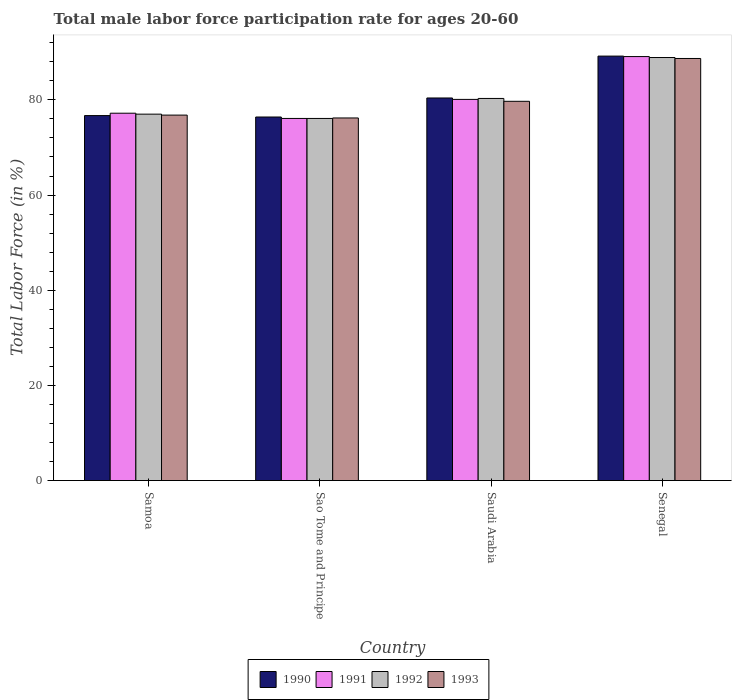How many bars are there on the 1st tick from the left?
Offer a terse response. 4. What is the label of the 1st group of bars from the left?
Offer a terse response. Samoa. What is the male labor force participation rate in 1990 in Sao Tome and Principe?
Make the answer very short. 76.4. Across all countries, what is the maximum male labor force participation rate in 1991?
Your answer should be very brief. 89.1. Across all countries, what is the minimum male labor force participation rate in 1993?
Your answer should be very brief. 76.2. In which country was the male labor force participation rate in 1992 maximum?
Give a very brief answer. Senegal. In which country was the male labor force participation rate in 1993 minimum?
Keep it short and to the point. Sao Tome and Principe. What is the total male labor force participation rate in 1990 in the graph?
Your response must be concise. 322.7. What is the difference between the male labor force participation rate in 1992 in Sao Tome and Principe and that in Saudi Arabia?
Offer a very short reply. -4.2. What is the average male labor force participation rate in 1993 per country?
Offer a very short reply. 80.35. What is the difference between the male labor force participation rate of/in 1990 and male labor force participation rate of/in 1993 in Saudi Arabia?
Keep it short and to the point. 0.7. In how many countries, is the male labor force participation rate in 1990 greater than 52 %?
Your answer should be very brief. 4. What is the ratio of the male labor force participation rate in 1990 in Samoa to that in Saudi Arabia?
Provide a short and direct response. 0.95. Is the difference between the male labor force participation rate in 1990 in Sao Tome and Principe and Senegal greater than the difference between the male labor force participation rate in 1993 in Sao Tome and Principe and Senegal?
Provide a short and direct response. No. What is the difference between the highest and the second highest male labor force participation rate in 1993?
Offer a very short reply. 11.9. In how many countries, is the male labor force participation rate in 1992 greater than the average male labor force participation rate in 1992 taken over all countries?
Provide a short and direct response. 1. Is the sum of the male labor force participation rate in 1993 in Sao Tome and Principe and Senegal greater than the maximum male labor force participation rate in 1991 across all countries?
Your answer should be very brief. Yes. How many countries are there in the graph?
Give a very brief answer. 4. What is the difference between two consecutive major ticks on the Y-axis?
Offer a terse response. 20. Does the graph contain grids?
Your answer should be compact. No. How are the legend labels stacked?
Offer a terse response. Horizontal. What is the title of the graph?
Make the answer very short. Total male labor force participation rate for ages 20-60. Does "2012" appear as one of the legend labels in the graph?
Give a very brief answer. No. What is the label or title of the X-axis?
Your response must be concise. Country. What is the Total Labor Force (in %) of 1990 in Samoa?
Give a very brief answer. 76.7. What is the Total Labor Force (in %) of 1991 in Samoa?
Your answer should be very brief. 77.2. What is the Total Labor Force (in %) in 1992 in Samoa?
Your answer should be very brief. 77. What is the Total Labor Force (in %) in 1993 in Samoa?
Make the answer very short. 76.8. What is the Total Labor Force (in %) of 1990 in Sao Tome and Principe?
Provide a succinct answer. 76.4. What is the Total Labor Force (in %) of 1991 in Sao Tome and Principe?
Keep it short and to the point. 76.1. What is the Total Labor Force (in %) in 1992 in Sao Tome and Principe?
Provide a short and direct response. 76.1. What is the Total Labor Force (in %) in 1993 in Sao Tome and Principe?
Ensure brevity in your answer.  76.2. What is the Total Labor Force (in %) of 1990 in Saudi Arabia?
Ensure brevity in your answer.  80.4. What is the Total Labor Force (in %) of 1991 in Saudi Arabia?
Provide a short and direct response. 80.1. What is the Total Labor Force (in %) in 1992 in Saudi Arabia?
Offer a terse response. 80.3. What is the Total Labor Force (in %) in 1993 in Saudi Arabia?
Your response must be concise. 79.7. What is the Total Labor Force (in %) of 1990 in Senegal?
Your response must be concise. 89.2. What is the Total Labor Force (in %) of 1991 in Senegal?
Offer a terse response. 89.1. What is the Total Labor Force (in %) in 1992 in Senegal?
Ensure brevity in your answer.  88.9. What is the Total Labor Force (in %) in 1993 in Senegal?
Your answer should be very brief. 88.7. Across all countries, what is the maximum Total Labor Force (in %) of 1990?
Offer a very short reply. 89.2. Across all countries, what is the maximum Total Labor Force (in %) of 1991?
Make the answer very short. 89.1. Across all countries, what is the maximum Total Labor Force (in %) in 1992?
Offer a very short reply. 88.9. Across all countries, what is the maximum Total Labor Force (in %) in 1993?
Your answer should be very brief. 88.7. Across all countries, what is the minimum Total Labor Force (in %) of 1990?
Your response must be concise. 76.4. Across all countries, what is the minimum Total Labor Force (in %) of 1991?
Your answer should be compact. 76.1. Across all countries, what is the minimum Total Labor Force (in %) in 1992?
Give a very brief answer. 76.1. Across all countries, what is the minimum Total Labor Force (in %) in 1993?
Provide a succinct answer. 76.2. What is the total Total Labor Force (in %) in 1990 in the graph?
Your answer should be compact. 322.7. What is the total Total Labor Force (in %) in 1991 in the graph?
Give a very brief answer. 322.5. What is the total Total Labor Force (in %) in 1992 in the graph?
Make the answer very short. 322.3. What is the total Total Labor Force (in %) of 1993 in the graph?
Your response must be concise. 321.4. What is the difference between the Total Labor Force (in %) in 1992 in Samoa and that in Sao Tome and Principe?
Provide a succinct answer. 0.9. What is the difference between the Total Labor Force (in %) in 1993 in Samoa and that in Sao Tome and Principe?
Provide a succinct answer. 0.6. What is the difference between the Total Labor Force (in %) of 1992 in Samoa and that in Senegal?
Ensure brevity in your answer.  -11.9. What is the difference between the Total Labor Force (in %) of 1993 in Samoa and that in Senegal?
Ensure brevity in your answer.  -11.9. What is the difference between the Total Labor Force (in %) of 1993 in Sao Tome and Principe and that in Senegal?
Keep it short and to the point. -12.5. What is the difference between the Total Labor Force (in %) of 1992 in Saudi Arabia and that in Senegal?
Provide a succinct answer. -8.6. What is the difference between the Total Labor Force (in %) of 1990 in Samoa and the Total Labor Force (in %) of 1992 in Sao Tome and Principe?
Your answer should be compact. 0.6. What is the difference between the Total Labor Force (in %) of 1990 in Samoa and the Total Labor Force (in %) of 1993 in Sao Tome and Principe?
Your answer should be compact. 0.5. What is the difference between the Total Labor Force (in %) in 1990 in Samoa and the Total Labor Force (in %) in 1991 in Saudi Arabia?
Provide a succinct answer. -3.4. What is the difference between the Total Labor Force (in %) in 1990 in Samoa and the Total Labor Force (in %) in 1992 in Saudi Arabia?
Make the answer very short. -3.6. What is the difference between the Total Labor Force (in %) of 1990 in Samoa and the Total Labor Force (in %) of 1993 in Saudi Arabia?
Ensure brevity in your answer.  -3. What is the difference between the Total Labor Force (in %) of 1991 in Samoa and the Total Labor Force (in %) of 1992 in Saudi Arabia?
Your answer should be very brief. -3.1. What is the difference between the Total Labor Force (in %) in 1991 in Samoa and the Total Labor Force (in %) in 1993 in Saudi Arabia?
Provide a short and direct response. -2.5. What is the difference between the Total Labor Force (in %) of 1992 in Samoa and the Total Labor Force (in %) of 1993 in Saudi Arabia?
Provide a succinct answer. -2.7. What is the difference between the Total Labor Force (in %) in 1990 in Samoa and the Total Labor Force (in %) in 1991 in Senegal?
Provide a succinct answer. -12.4. What is the difference between the Total Labor Force (in %) of 1990 in Samoa and the Total Labor Force (in %) of 1992 in Senegal?
Your answer should be very brief. -12.2. What is the difference between the Total Labor Force (in %) of 1990 in Samoa and the Total Labor Force (in %) of 1993 in Senegal?
Make the answer very short. -12. What is the difference between the Total Labor Force (in %) of 1991 in Samoa and the Total Labor Force (in %) of 1992 in Senegal?
Make the answer very short. -11.7. What is the difference between the Total Labor Force (in %) in 1992 in Samoa and the Total Labor Force (in %) in 1993 in Senegal?
Offer a very short reply. -11.7. What is the difference between the Total Labor Force (in %) of 1991 in Sao Tome and Principe and the Total Labor Force (in %) of 1993 in Saudi Arabia?
Make the answer very short. -3.6. What is the difference between the Total Labor Force (in %) of 1992 in Sao Tome and Principe and the Total Labor Force (in %) of 1993 in Saudi Arabia?
Offer a terse response. -3.6. What is the difference between the Total Labor Force (in %) in 1990 in Sao Tome and Principe and the Total Labor Force (in %) in 1992 in Senegal?
Offer a terse response. -12.5. What is the difference between the Total Labor Force (in %) in 1990 in Sao Tome and Principe and the Total Labor Force (in %) in 1993 in Senegal?
Give a very brief answer. -12.3. What is the difference between the Total Labor Force (in %) of 1991 in Sao Tome and Principe and the Total Labor Force (in %) of 1992 in Senegal?
Your answer should be compact. -12.8. What is the difference between the Total Labor Force (in %) of 1991 in Sao Tome and Principe and the Total Labor Force (in %) of 1993 in Senegal?
Give a very brief answer. -12.6. What is the difference between the Total Labor Force (in %) of 1990 in Saudi Arabia and the Total Labor Force (in %) of 1991 in Senegal?
Your answer should be very brief. -8.7. What is the difference between the Total Labor Force (in %) of 1990 in Saudi Arabia and the Total Labor Force (in %) of 1992 in Senegal?
Provide a short and direct response. -8.5. What is the difference between the Total Labor Force (in %) of 1991 in Saudi Arabia and the Total Labor Force (in %) of 1993 in Senegal?
Offer a terse response. -8.6. What is the average Total Labor Force (in %) of 1990 per country?
Ensure brevity in your answer.  80.67. What is the average Total Labor Force (in %) in 1991 per country?
Your answer should be very brief. 80.62. What is the average Total Labor Force (in %) of 1992 per country?
Give a very brief answer. 80.58. What is the average Total Labor Force (in %) of 1993 per country?
Offer a terse response. 80.35. What is the difference between the Total Labor Force (in %) of 1990 and Total Labor Force (in %) of 1991 in Samoa?
Offer a very short reply. -0.5. What is the difference between the Total Labor Force (in %) of 1990 and Total Labor Force (in %) of 1992 in Samoa?
Your response must be concise. -0.3. What is the difference between the Total Labor Force (in %) in 1990 and Total Labor Force (in %) in 1993 in Samoa?
Ensure brevity in your answer.  -0.1. What is the difference between the Total Labor Force (in %) in 1991 and Total Labor Force (in %) in 1992 in Samoa?
Your answer should be compact. 0.2. What is the difference between the Total Labor Force (in %) in 1991 and Total Labor Force (in %) in 1993 in Samoa?
Keep it short and to the point. 0.4. What is the difference between the Total Labor Force (in %) of 1992 and Total Labor Force (in %) of 1993 in Samoa?
Keep it short and to the point. 0.2. What is the difference between the Total Labor Force (in %) of 1990 and Total Labor Force (in %) of 1991 in Sao Tome and Principe?
Make the answer very short. 0.3. What is the difference between the Total Labor Force (in %) of 1990 and Total Labor Force (in %) of 1992 in Sao Tome and Principe?
Your answer should be very brief. 0.3. What is the difference between the Total Labor Force (in %) in 1991 and Total Labor Force (in %) in 1993 in Sao Tome and Principe?
Keep it short and to the point. -0.1. What is the difference between the Total Labor Force (in %) in 1992 and Total Labor Force (in %) in 1993 in Sao Tome and Principe?
Provide a succinct answer. -0.1. What is the difference between the Total Labor Force (in %) of 1990 and Total Labor Force (in %) of 1993 in Saudi Arabia?
Your answer should be compact. 0.7. What is the difference between the Total Labor Force (in %) of 1991 and Total Labor Force (in %) of 1992 in Saudi Arabia?
Give a very brief answer. -0.2. What is the difference between the Total Labor Force (in %) of 1991 and Total Labor Force (in %) of 1993 in Saudi Arabia?
Provide a short and direct response. 0.4. What is the difference between the Total Labor Force (in %) in 1992 and Total Labor Force (in %) in 1993 in Saudi Arabia?
Offer a terse response. 0.6. What is the difference between the Total Labor Force (in %) of 1991 and Total Labor Force (in %) of 1993 in Senegal?
Offer a terse response. 0.4. What is the difference between the Total Labor Force (in %) in 1992 and Total Labor Force (in %) in 1993 in Senegal?
Your answer should be very brief. 0.2. What is the ratio of the Total Labor Force (in %) of 1991 in Samoa to that in Sao Tome and Principe?
Make the answer very short. 1.01. What is the ratio of the Total Labor Force (in %) in 1992 in Samoa to that in Sao Tome and Principe?
Provide a short and direct response. 1.01. What is the ratio of the Total Labor Force (in %) of 1993 in Samoa to that in Sao Tome and Principe?
Your answer should be very brief. 1.01. What is the ratio of the Total Labor Force (in %) of 1990 in Samoa to that in Saudi Arabia?
Make the answer very short. 0.95. What is the ratio of the Total Labor Force (in %) in 1991 in Samoa to that in Saudi Arabia?
Provide a succinct answer. 0.96. What is the ratio of the Total Labor Force (in %) of 1992 in Samoa to that in Saudi Arabia?
Offer a very short reply. 0.96. What is the ratio of the Total Labor Force (in %) in 1993 in Samoa to that in Saudi Arabia?
Offer a very short reply. 0.96. What is the ratio of the Total Labor Force (in %) in 1990 in Samoa to that in Senegal?
Offer a terse response. 0.86. What is the ratio of the Total Labor Force (in %) in 1991 in Samoa to that in Senegal?
Your answer should be very brief. 0.87. What is the ratio of the Total Labor Force (in %) in 1992 in Samoa to that in Senegal?
Offer a very short reply. 0.87. What is the ratio of the Total Labor Force (in %) in 1993 in Samoa to that in Senegal?
Your answer should be very brief. 0.87. What is the ratio of the Total Labor Force (in %) of 1990 in Sao Tome and Principe to that in Saudi Arabia?
Provide a succinct answer. 0.95. What is the ratio of the Total Labor Force (in %) in 1991 in Sao Tome and Principe to that in Saudi Arabia?
Ensure brevity in your answer.  0.95. What is the ratio of the Total Labor Force (in %) of 1992 in Sao Tome and Principe to that in Saudi Arabia?
Offer a terse response. 0.95. What is the ratio of the Total Labor Force (in %) in 1993 in Sao Tome and Principe to that in Saudi Arabia?
Your response must be concise. 0.96. What is the ratio of the Total Labor Force (in %) in 1990 in Sao Tome and Principe to that in Senegal?
Offer a terse response. 0.86. What is the ratio of the Total Labor Force (in %) of 1991 in Sao Tome and Principe to that in Senegal?
Offer a terse response. 0.85. What is the ratio of the Total Labor Force (in %) in 1992 in Sao Tome and Principe to that in Senegal?
Make the answer very short. 0.86. What is the ratio of the Total Labor Force (in %) in 1993 in Sao Tome and Principe to that in Senegal?
Ensure brevity in your answer.  0.86. What is the ratio of the Total Labor Force (in %) of 1990 in Saudi Arabia to that in Senegal?
Your answer should be compact. 0.9. What is the ratio of the Total Labor Force (in %) of 1991 in Saudi Arabia to that in Senegal?
Offer a very short reply. 0.9. What is the ratio of the Total Labor Force (in %) in 1992 in Saudi Arabia to that in Senegal?
Give a very brief answer. 0.9. What is the ratio of the Total Labor Force (in %) in 1993 in Saudi Arabia to that in Senegal?
Your response must be concise. 0.9. What is the difference between the highest and the second highest Total Labor Force (in %) of 1991?
Offer a very short reply. 9. What is the difference between the highest and the second highest Total Labor Force (in %) of 1992?
Offer a terse response. 8.6. What is the difference between the highest and the second highest Total Labor Force (in %) of 1993?
Provide a short and direct response. 9. What is the difference between the highest and the lowest Total Labor Force (in %) of 1990?
Your answer should be very brief. 12.8. What is the difference between the highest and the lowest Total Labor Force (in %) of 1991?
Offer a terse response. 13. What is the difference between the highest and the lowest Total Labor Force (in %) in 1993?
Make the answer very short. 12.5. 